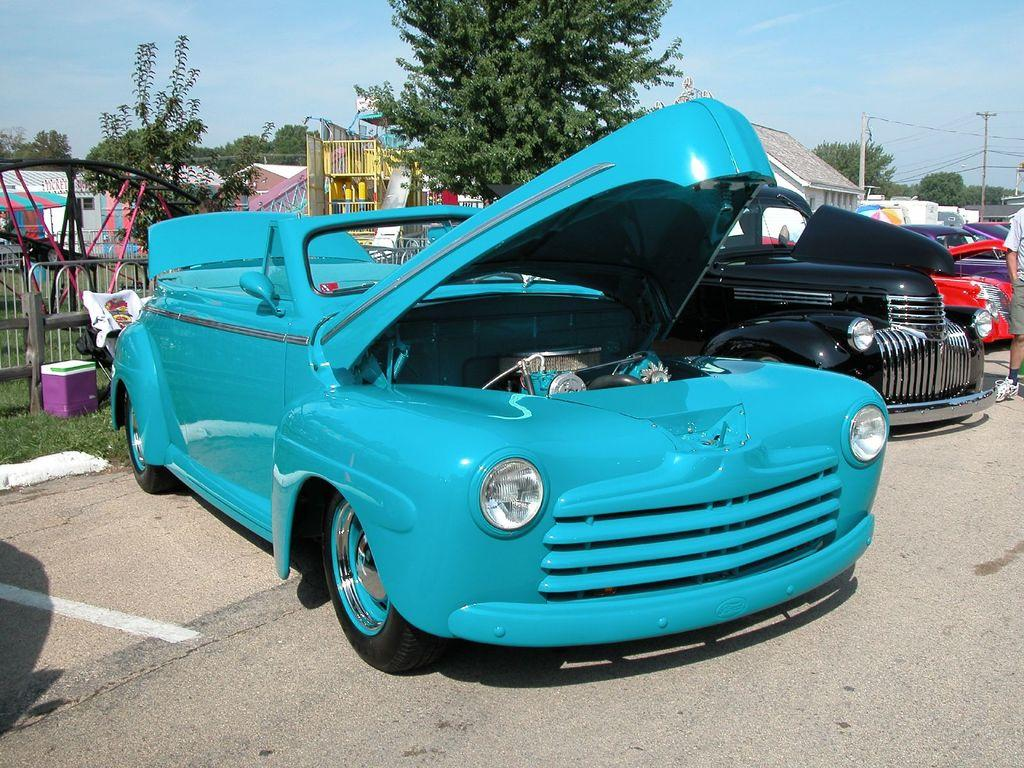What type of vehicles can be seen in the front of the image? There are cars in the front of the image. What can be seen in the distance behind the cars? In the background of the image, there are trees, poles, a fence, and buildings. What is the ground covered with in the image? There is grass on the ground in the image. What type of science experiment is being conducted with the quill in the image? There is no science experiment or quill present in the image. What curve can be seen in the image? There is no curve visible in the image. 